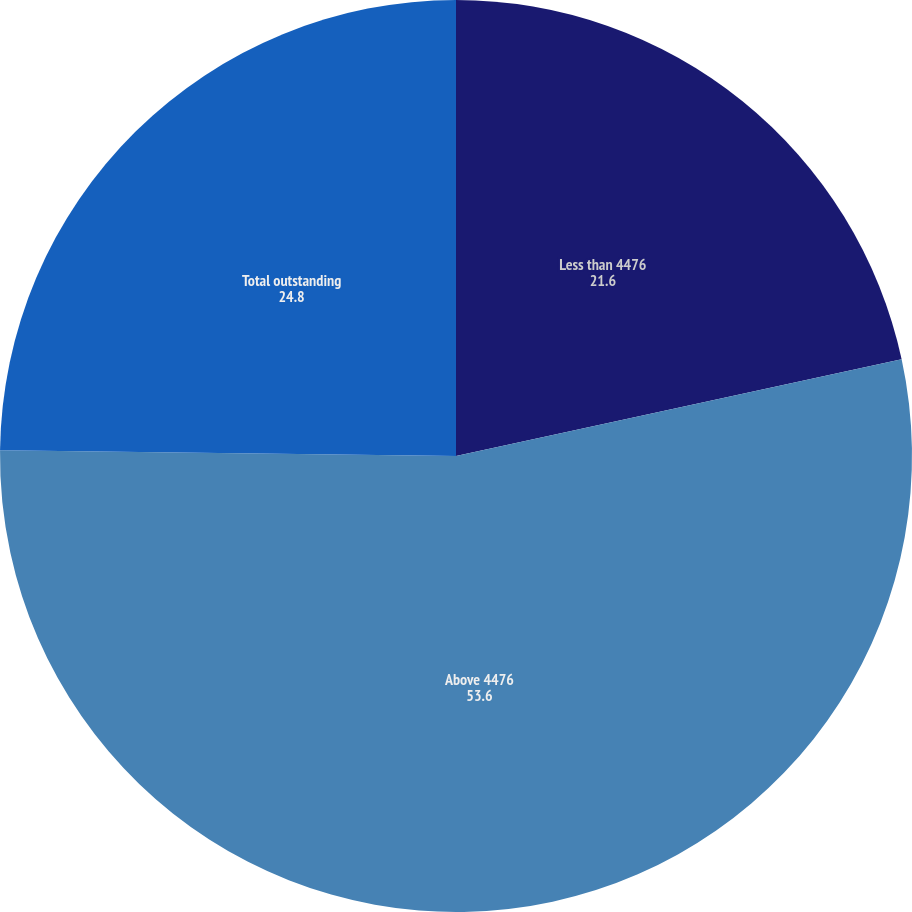Convert chart. <chart><loc_0><loc_0><loc_500><loc_500><pie_chart><fcel>Less than 4476<fcel>Above 4476<fcel>Total outstanding<nl><fcel>21.6%<fcel>53.6%<fcel>24.8%<nl></chart> 